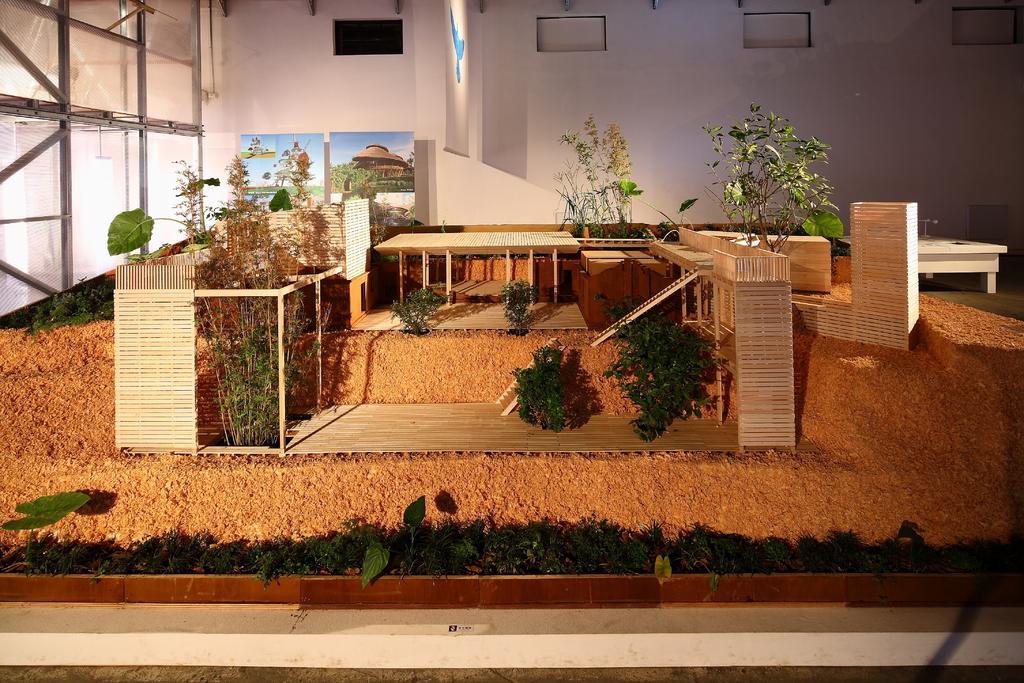Could you give a brief overview of what you see in this image? Here in this picture we can see tables and chairs kept on a place over there and we can see plants present all over there and we can see painting present on wall over there. 